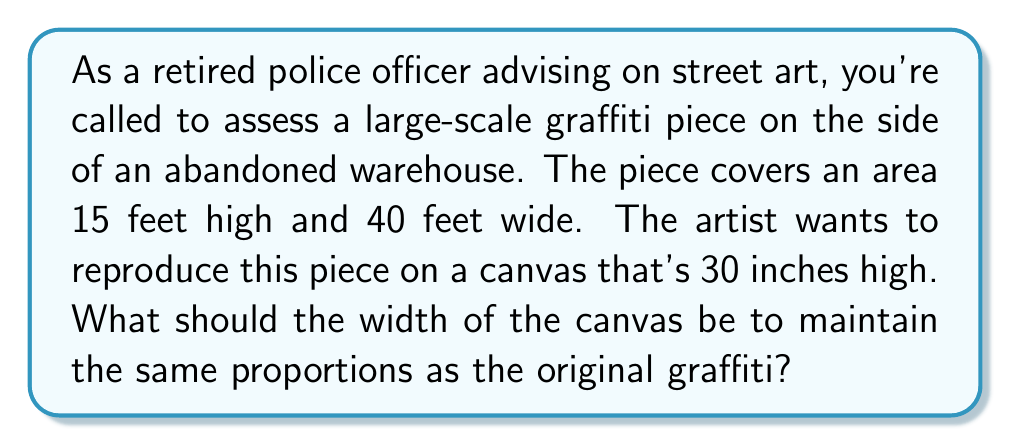Provide a solution to this math problem. To solve this problem, we need to use the concept of proportions. The key is to maintain the same ratio of height to width in both the original graffiti and the canvas reproduction.

Let's approach this step-by-step:

1) First, let's establish the ratio of the original graffiti:
   Original height : Original width = 15 feet : 40 feet

2) We can simplify this ratio:
   15 : 40 = 3 : 8

3) Now, we know that the canvas height will be 30 inches. We need to find the width (let's call it x) that maintains this 3:8 ratio.

4) We can set up a proportion:
   $$\frac{3}{8} = \frac{30}{x}$$

5) To solve for x, we cross-multiply:
   $$3x = 8 * 30$$
   $$3x = 240$$

6) Now we divide both sides by 3:
   $$x = \frac{240}{3} = 80$$

Therefore, to maintain the same proportions as the original graffiti, the canvas should be 80 inches wide.

We can verify this:
Original ratio: 15 : 40 = 3 : 8
Canvas ratio: 30 : 80 = 3 : 8

The ratios are indeed the same, confirming our calculation.
Answer: The canvas should be 80 inches wide to maintain the same proportions as the original graffiti piece. 